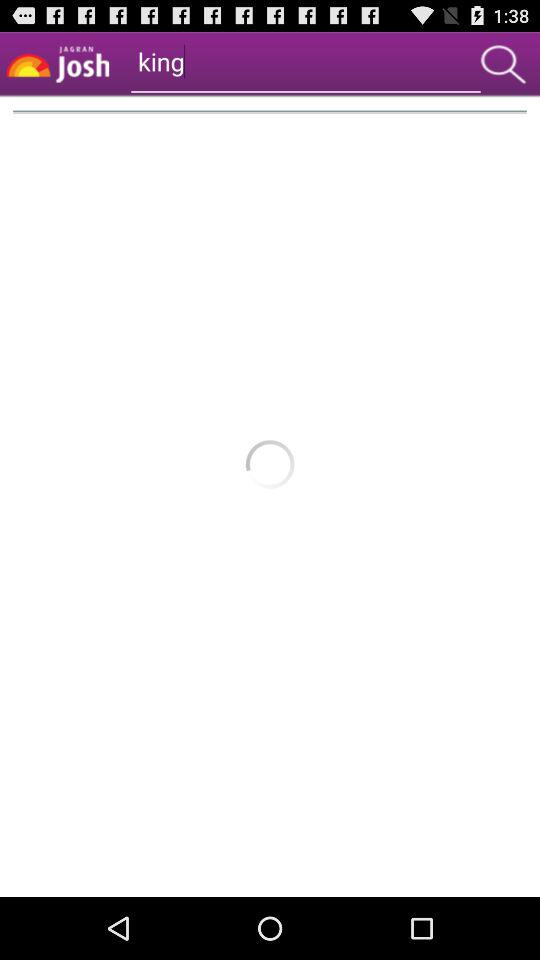What is the application name? The application name is "JAGRAN Josh". 